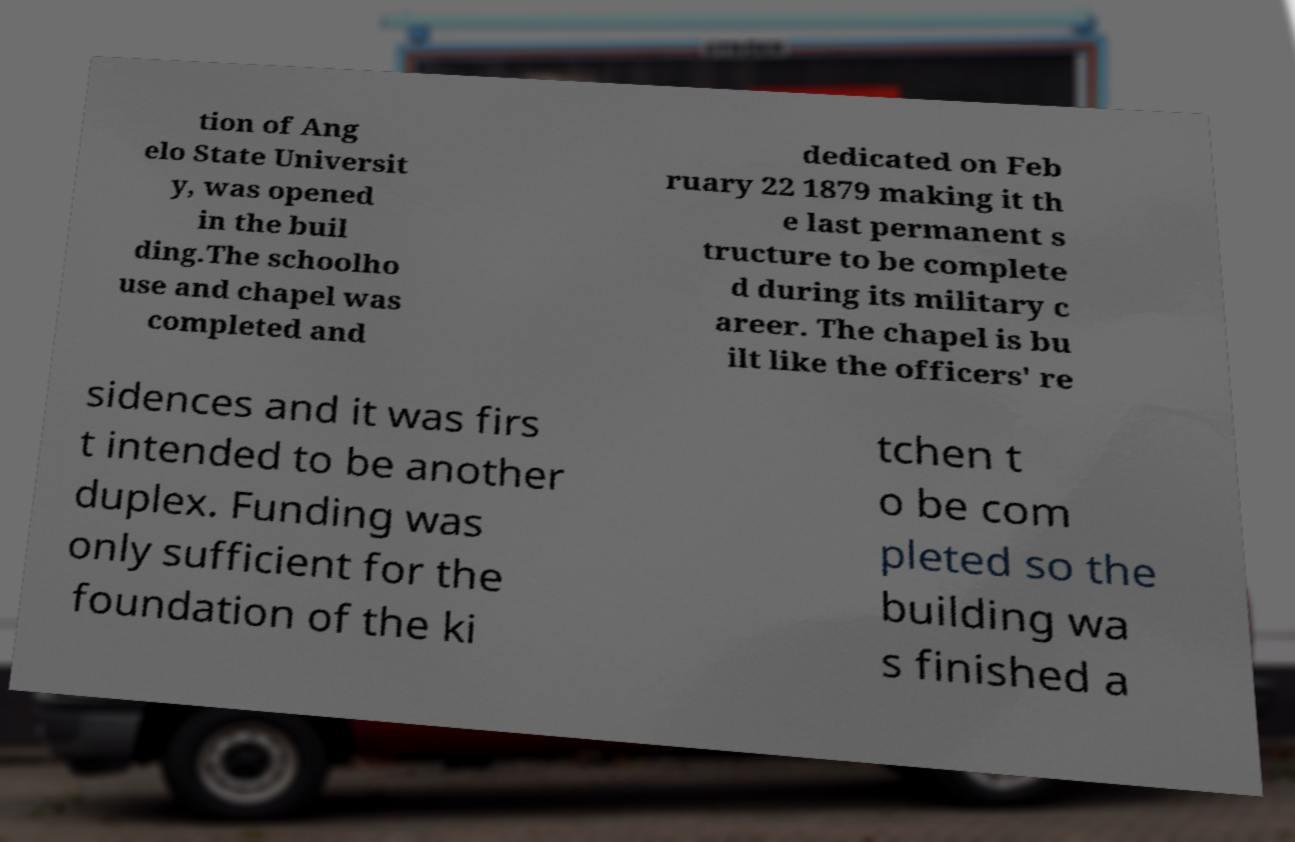Could you assist in decoding the text presented in this image and type it out clearly? tion of Ang elo State Universit y, was opened in the buil ding.The schoolho use and chapel was completed and dedicated on Feb ruary 22 1879 making it th e last permanent s tructure to be complete d during its military c areer. The chapel is bu ilt like the officers' re sidences and it was firs t intended to be another duplex. Funding was only sufficient for the foundation of the ki tchen t o be com pleted so the building wa s finished a 